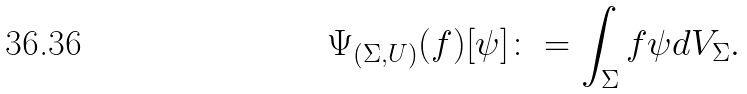<formula> <loc_0><loc_0><loc_500><loc_500>\Psi _ { ( \Sigma , U ) } ( f ) [ \psi ] \colon = \int _ { \Sigma } f \psi d V _ { \Sigma } .</formula> 